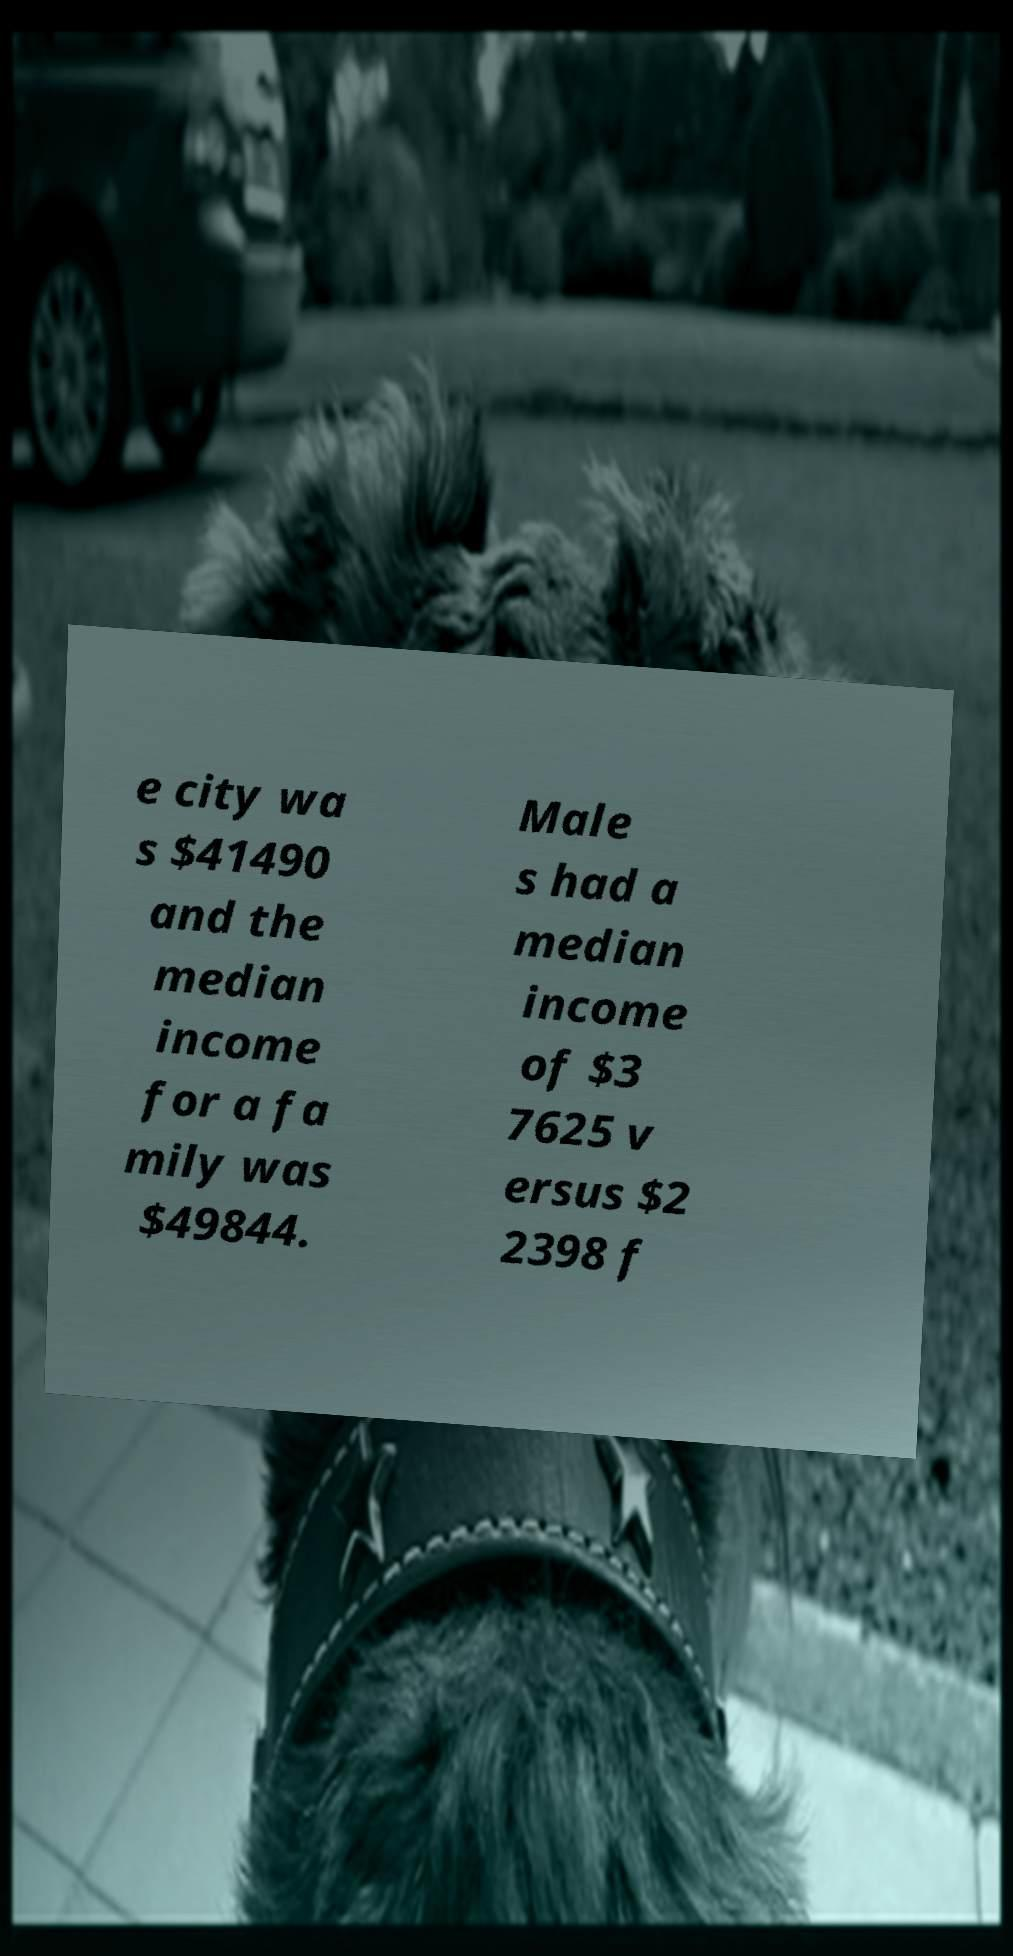Please read and relay the text visible in this image. What does it say? e city wa s $41490 and the median income for a fa mily was $49844. Male s had a median income of $3 7625 v ersus $2 2398 f 